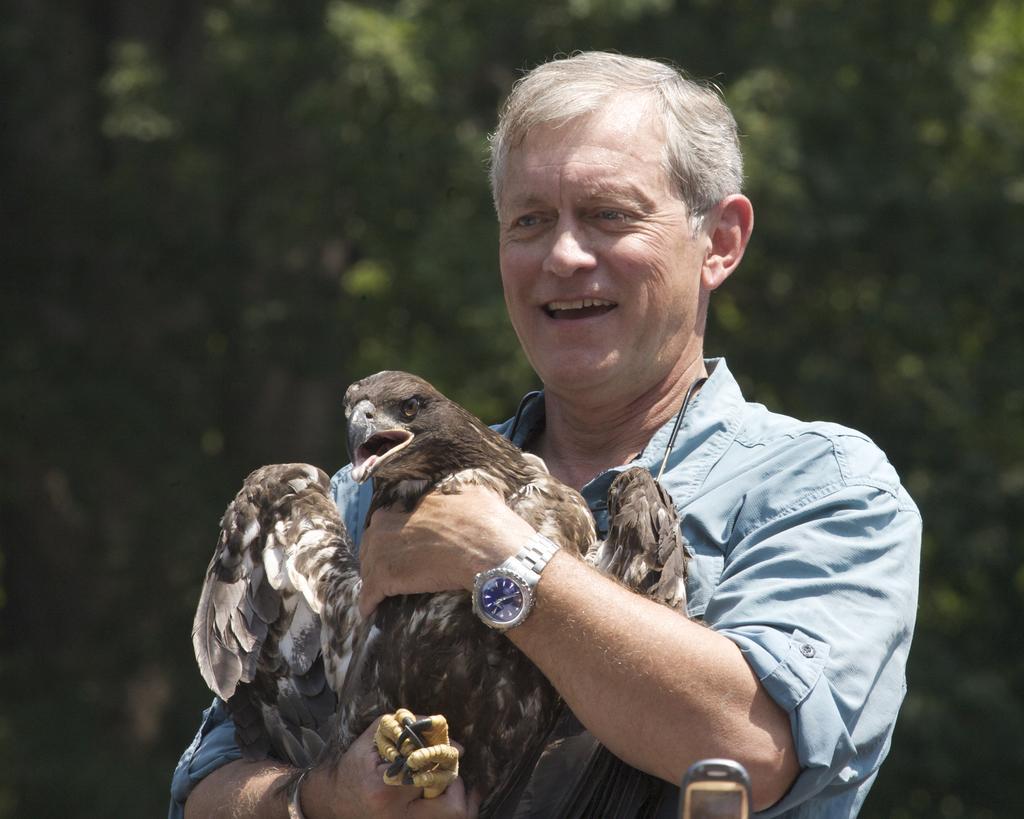How would you summarize this image in a sentence or two? In this image there is a person holding a bird, and at the background there are trees. 